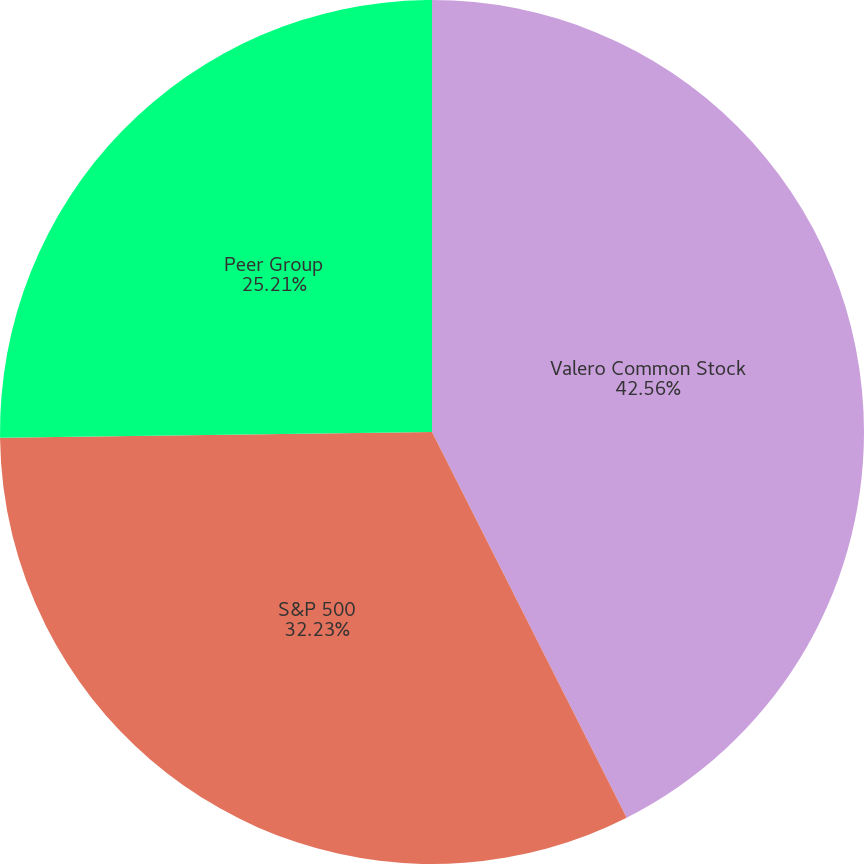<chart> <loc_0><loc_0><loc_500><loc_500><pie_chart><fcel>Valero Common Stock<fcel>S&P 500<fcel>Peer Group<nl><fcel>42.56%<fcel>32.23%<fcel>25.21%<nl></chart> 